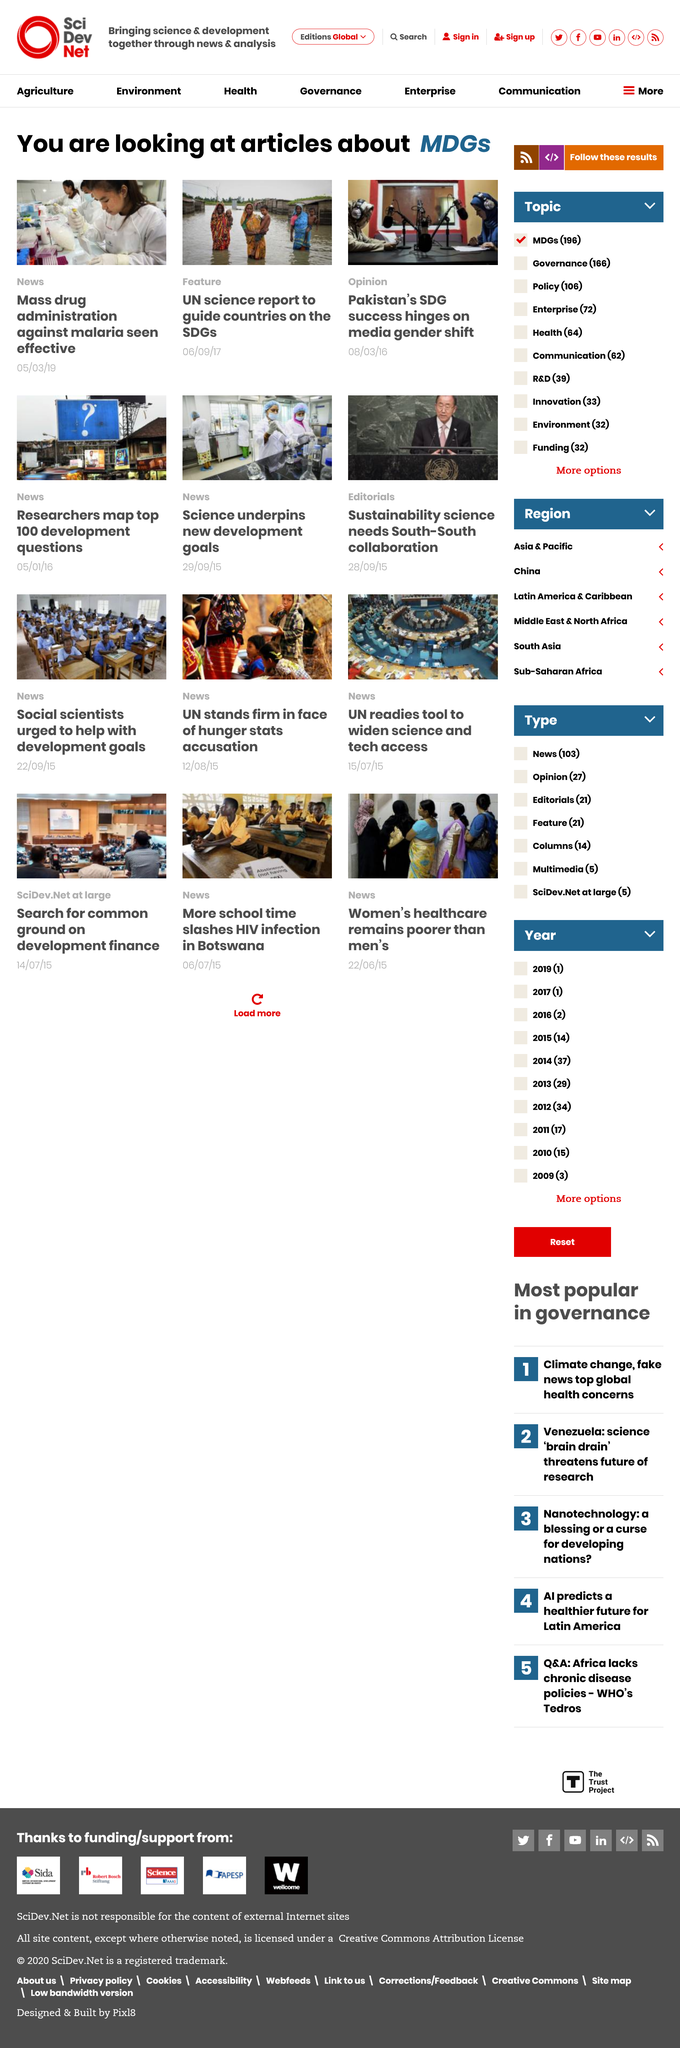Draw attention to some important aspects in this diagram. The United Nations published a science report that guides countries on achieving the Sustainable Development Goals. The articles discuss the Millennium Development Goals, which are a set of eight objectives aimed at reducing poverty and improving the lives of people around the world. On September 6, 2017, the article "UN science report to guide countries on SDGs" was published. 